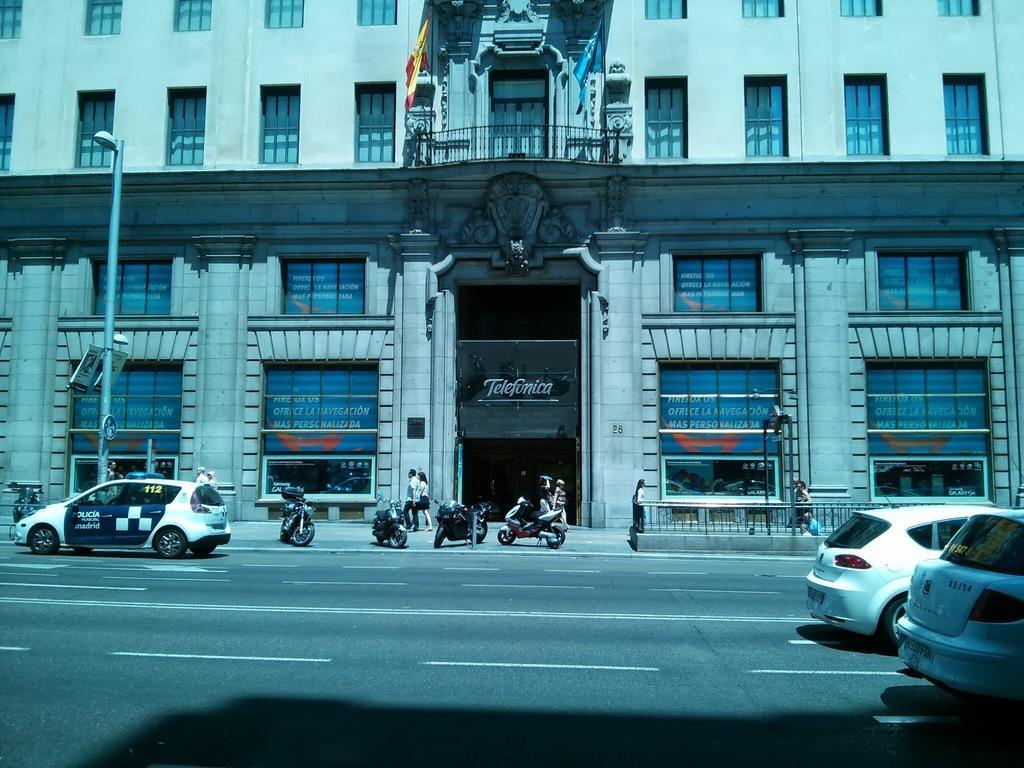How would you summarize this image in a sentence or two? In this image I can see the road, few vehicles on the road, few motor bikes, a sidewalk, few persons standing on the sidewalk, the railing, a pole, few boards and light to the pole and in the background I can see a building, few banners and windows to the building and two flags which are yellow, red and blue in color. 